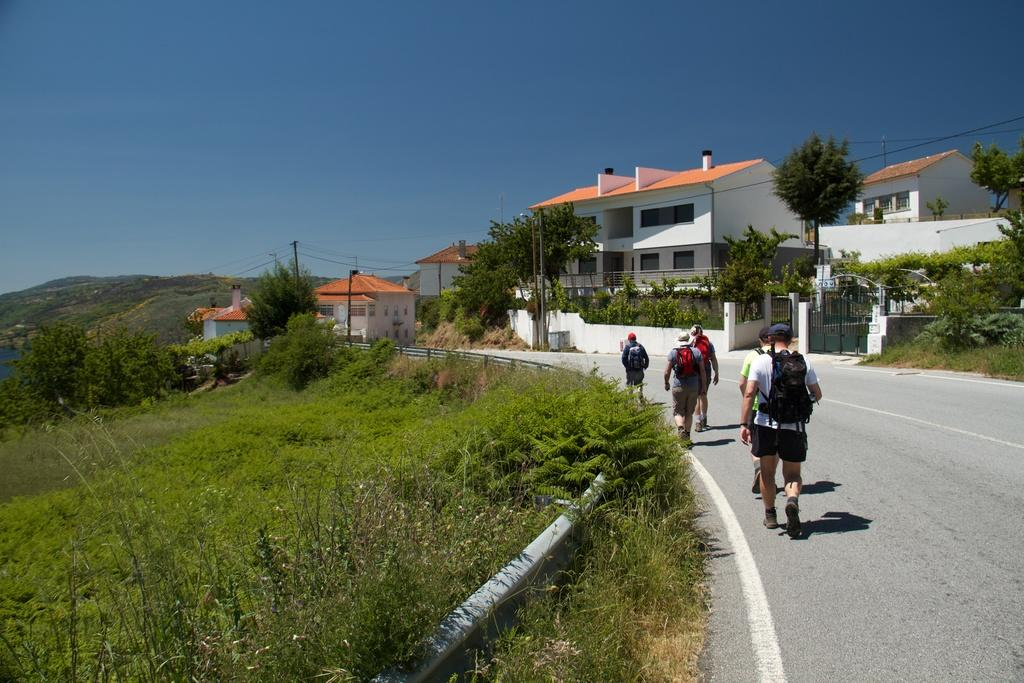What are the men in the foreground of the image doing? The men in the foreground of the image are walking on the ground. What can be seen in the background of the image? In the background of the image, there are houses, trees, poles, a railing, plants, mountains, and the sky. Can you describe the natural environment visible in the image? The natural environment includes trees, plants, mountains, and the sky. Where is the river located in the image? There is no river present in the image. What type of card is being used by the men in the image? There are no cards present in the image; the men are walking on the ground. 